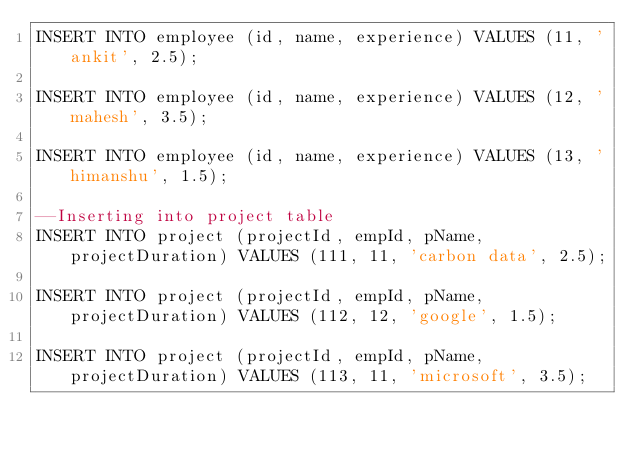<code> <loc_0><loc_0><loc_500><loc_500><_SQL_>INSERT INTO employee (id, name, experience) VALUES (11, 'ankit', 2.5);

INSERT INTO employee (id, name, experience) VALUES (12, 'mahesh', 3.5);

INSERT INTO employee (id, name, experience) VALUES (13, 'himanshu', 1.5);

--Inserting into project table
INSERT INTO project (projectId, empId, pName, projectDuration) VALUES (111, 11, 'carbon data', 2.5);

INSERT INTO project (projectId, empId, pName, projectDuration) VALUES (112, 12, 'google', 1.5);

INSERT INTO project (projectId, empId, pName, projectDuration) VALUES (113, 11, 'microsoft', 3.5);


</code> 